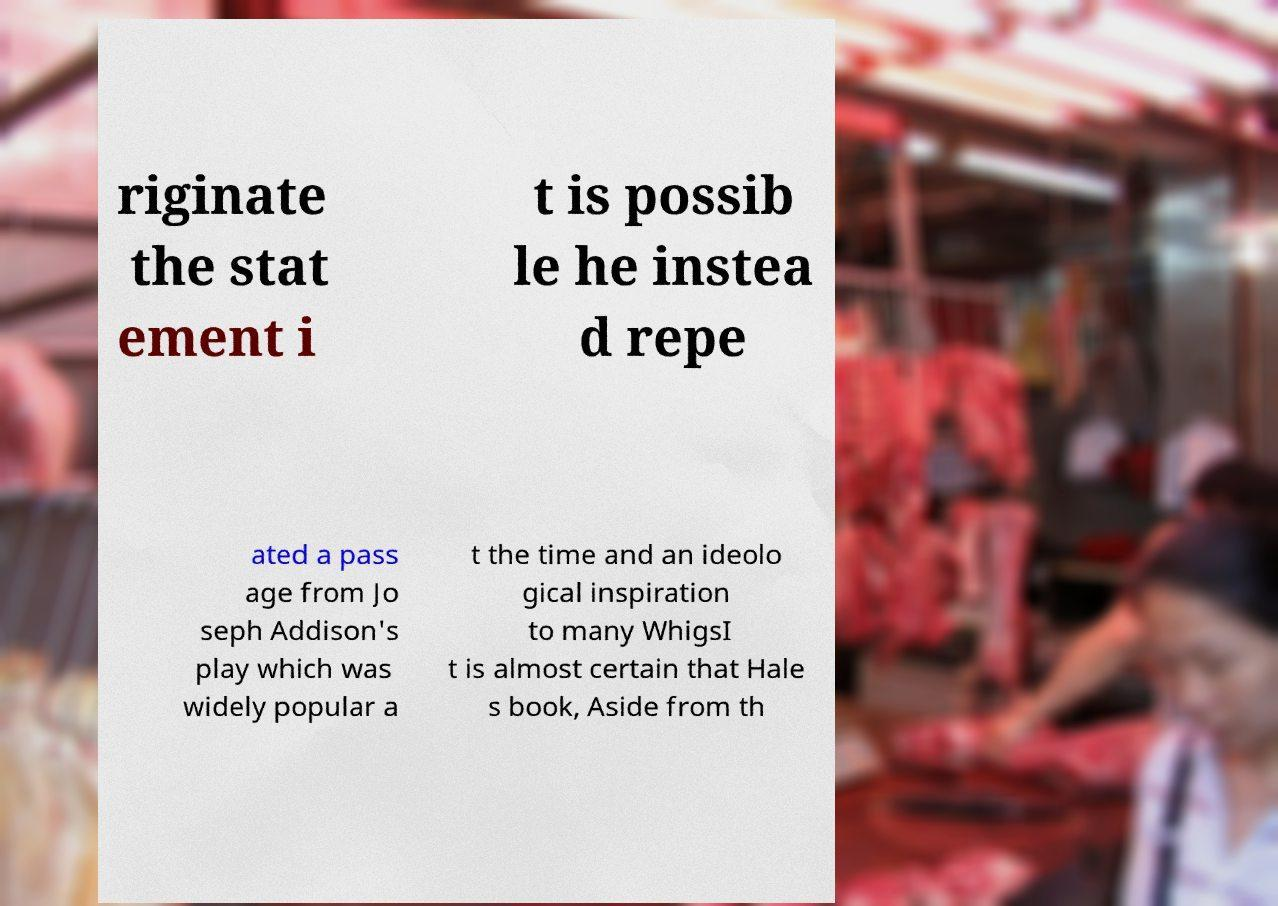I need the written content from this picture converted into text. Can you do that? riginate the stat ement i t is possib le he instea d repe ated a pass age from Jo seph Addison's play which was widely popular a t the time and an ideolo gical inspiration to many WhigsI t is almost certain that Hale s book, Aside from th 